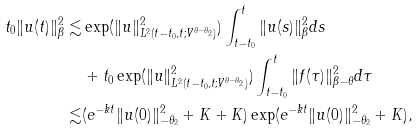Convert formula to latex. <formula><loc_0><loc_0><loc_500><loc_500>t _ { 0 } \| u ( t ) \| _ { \beta } ^ { 2 } \lesssim & \exp ( \| u \| _ { L ^ { 2 } ( t - t _ { 0 } , t ; V ^ { \theta - \theta _ { 2 } } ) } ^ { 2 } ) \int _ { t - t _ { 0 } } ^ { t } \| u ( s ) \| _ { \beta } ^ { 2 } d s \\ & + t _ { 0 } \exp ( \| u \| _ { L ^ { 2 } ( t - t _ { 0 } , t ; V ^ { \theta - \theta _ { 2 } } ) } ^ { 2 } ) \int _ { t - t _ { 0 } } ^ { t } \| f ( \tau ) \| _ { \beta - \theta } ^ { 2 } d \tau \\ \lesssim & ( e ^ { - k t } \| u ( 0 ) \| _ { - \theta _ { 2 } } ^ { 2 } + K + K ) \exp ( e ^ { - k t } \| u ( 0 ) \| _ { - \theta _ { 2 } } ^ { 2 } + K ) ,</formula> 